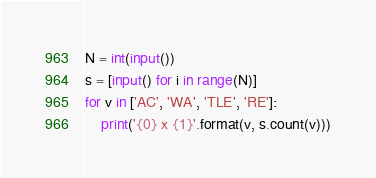<code> <loc_0><loc_0><loc_500><loc_500><_Python_>N = int(input())
s = [input() for i in range(N)]
for v in ['AC', 'WA', 'TLE', 'RE']:
    print('{0} x {1}'.format(v, s.count(v)))
</code> 